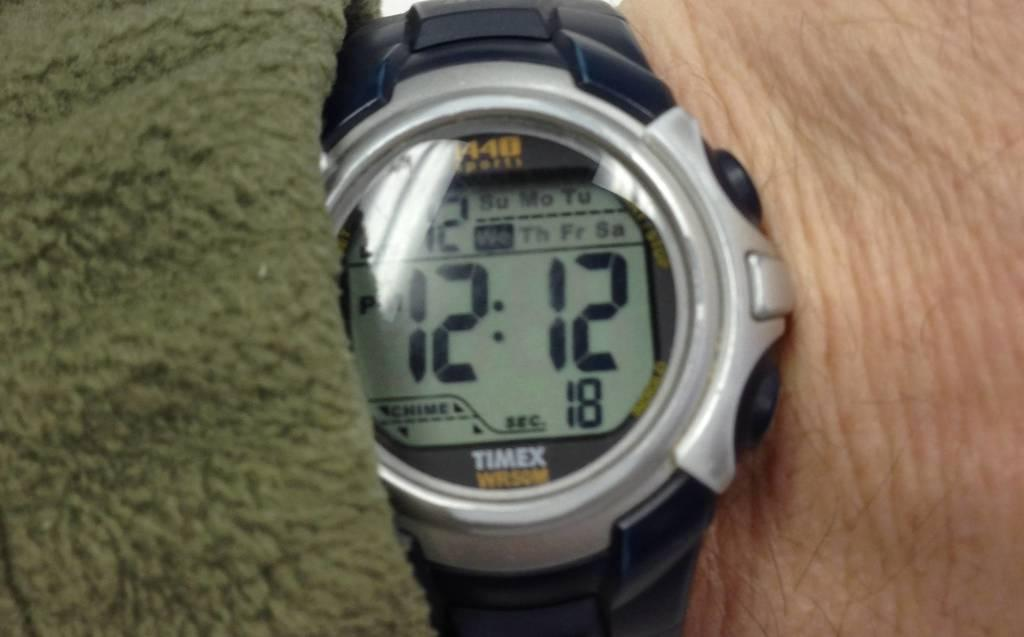<image>
Offer a succinct explanation of the picture presented. A black and grey Timex wrist watch with the time showing as 12:12. 